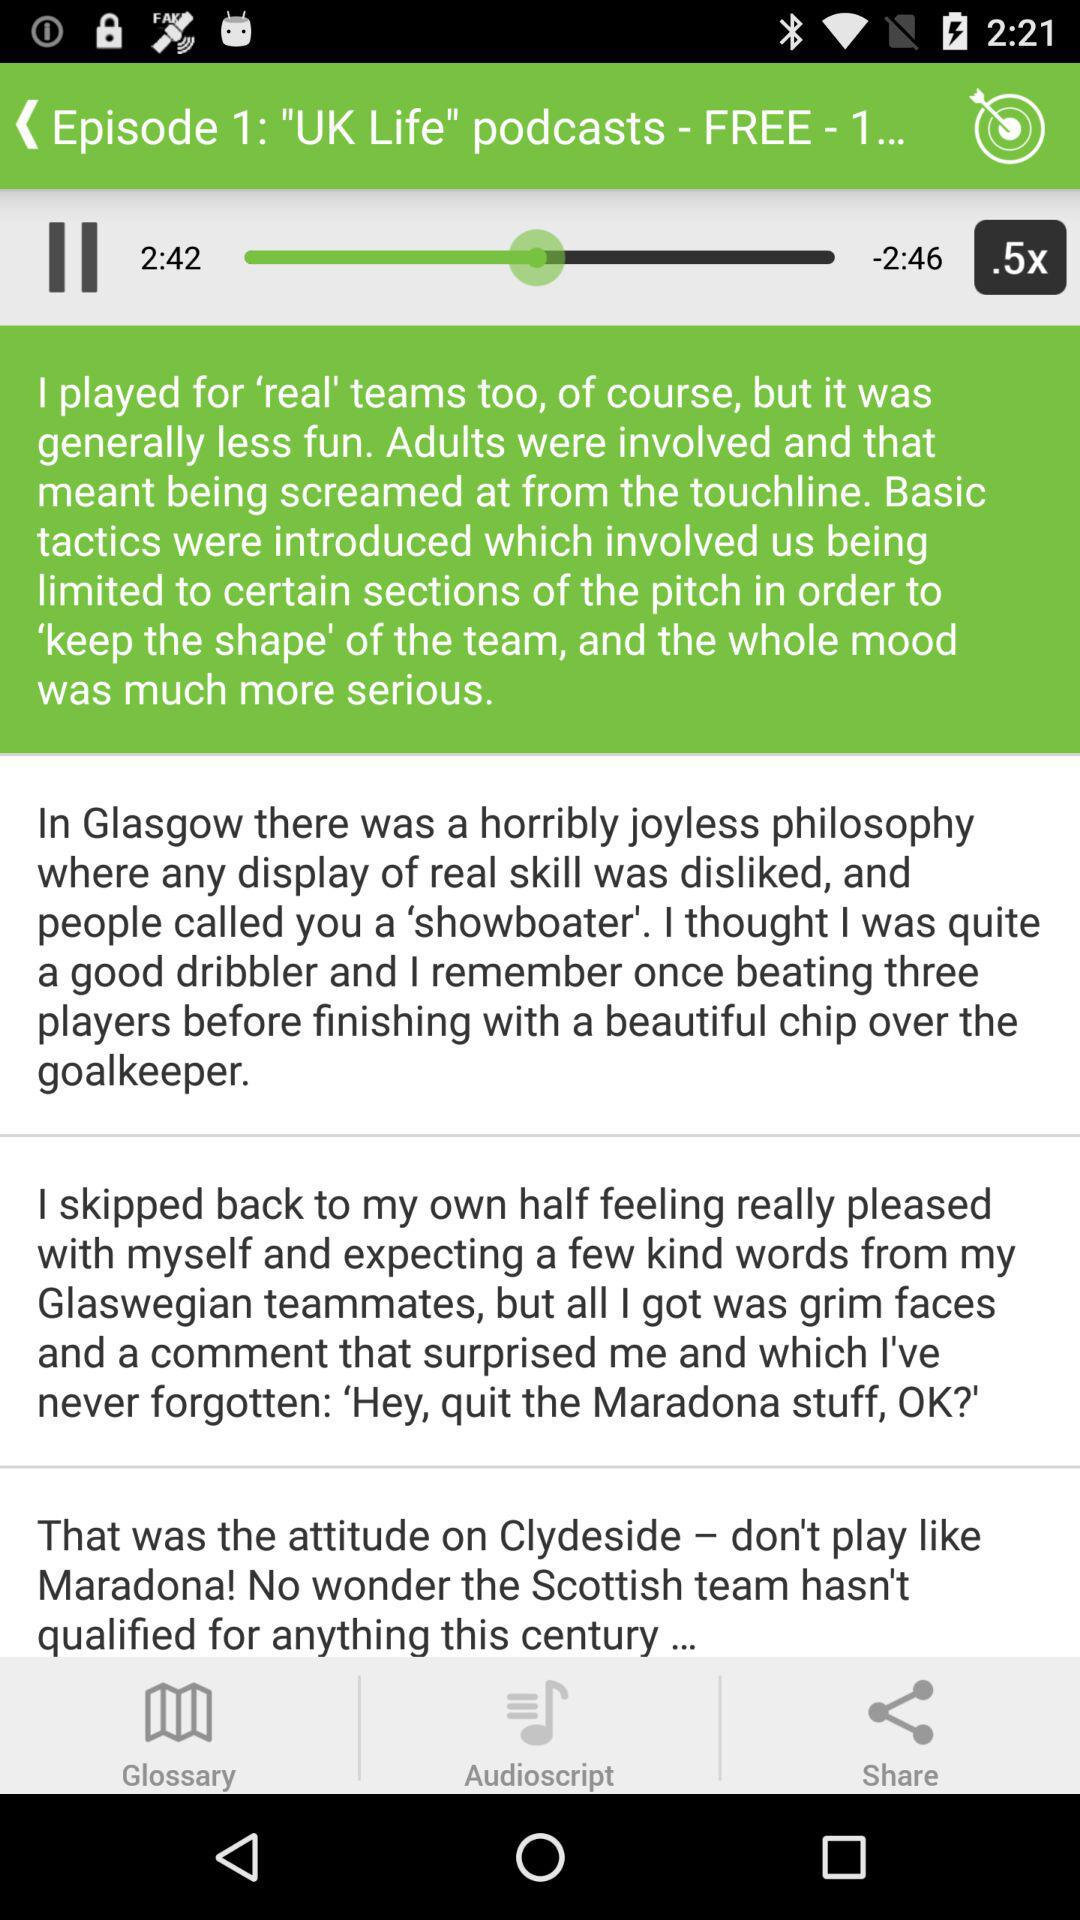What is the size? The size is 9.11 MB. 